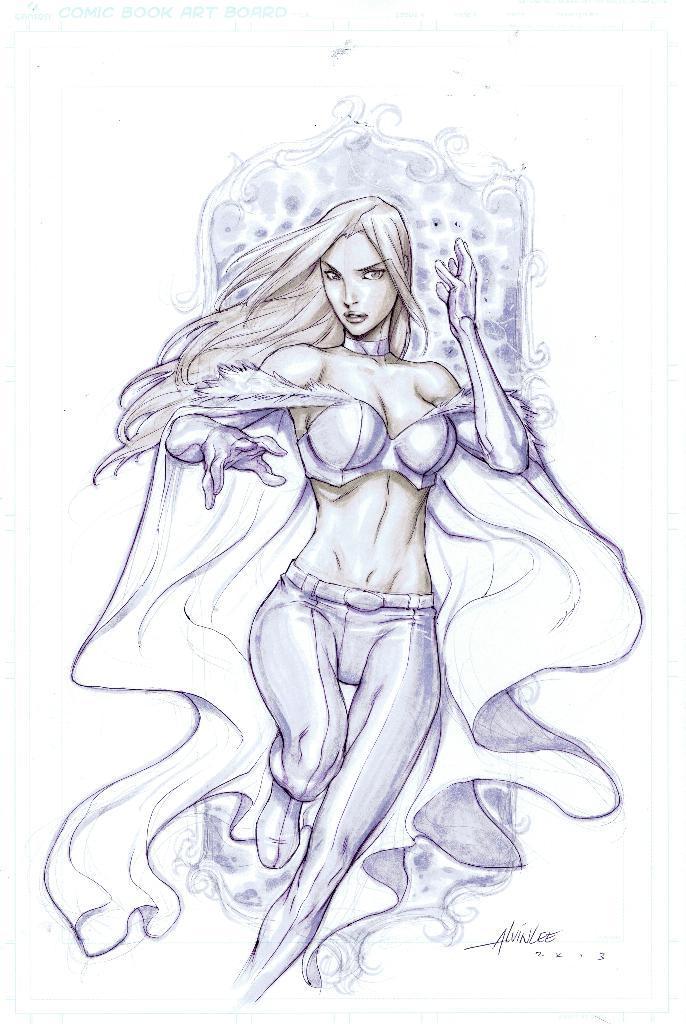Could you give a brief overview of what you see in this image? In this image I can see an art of the person and I can see the white color background. 